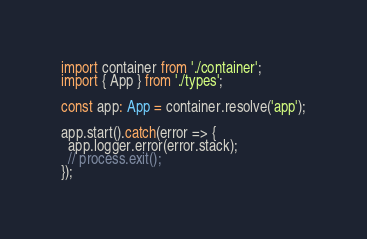Convert code to text. <code><loc_0><loc_0><loc_500><loc_500><_TypeScript_>import container from './container';
import { App } from './types';

const app: App = container.resolve('app');

app.start().catch(error => {
  app.logger.error(error.stack);
  // process.exit();
});
</code> 